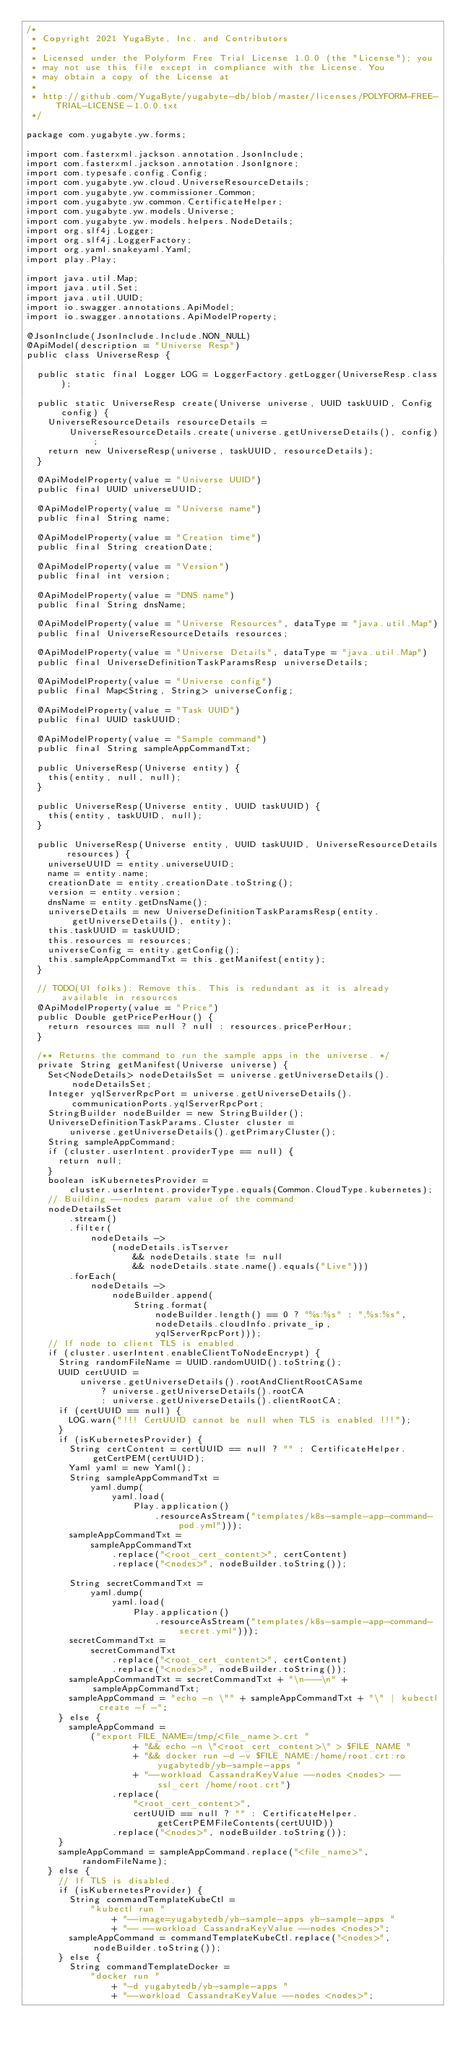<code> <loc_0><loc_0><loc_500><loc_500><_Java_>/*
 * Copyright 2021 YugaByte, Inc. and Contributors
 *
 * Licensed under the Polyform Free Trial License 1.0.0 (the "License"); you
 * may not use this file except in compliance with the License. You
 * may obtain a copy of the License at
 *
 * http://github.com/YugaByte/yugabyte-db/blob/master/licenses/POLYFORM-FREE-TRIAL-LICENSE-1.0.0.txt
 */

package com.yugabyte.yw.forms;

import com.fasterxml.jackson.annotation.JsonInclude;
import com.fasterxml.jackson.annotation.JsonIgnore;
import com.typesafe.config.Config;
import com.yugabyte.yw.cloud.UniverseResourceDetails;
import com.yugabyte.yw.commissioner.Common;
import com.yugabyte.yw.common.CertificateHelper;
import com.yugabyte.yw.models.Universe;
import com.yugabyte.yw.models.helpers.NodeDetails;
import org.slf4j.Logger;
import org.slf4j.LoggerFactory;
import org.yaml.snakeyaml.Yaml;
import play.Play;

import java.util.Map;
import java.util.Set;
import java.util.UUID;
import io.swagger.annotations.ApiModel;
import io.swagger.annotations.ApiModelProperty;

@JsonInclude(JsonInclude.Include.NON_NULL)
@ApiModel(description = "Universe Resp")
public class UniverseResp {

  public static final Logger LOG = LoggerFactory.getLogger(UniverseResp.class);

  public static UniverseResp create(Universe universe, UUID taskUUID, Config config) {
    UniverseResourceDetails resourceDetails =
        UniverseResourceDetails.create(universe.getUniverseDetails(), config);
    return new UniverseResp(universe, taskUUID, resourceDetails);
  }

  @ApiModelProperty(value = "Universe UUID")
  public final UUID universeUUID;

  @ApiModelProperty(value = "Universe name")
  public final String name;

  @ApiModelProperty(value = "Creation time")
  public final String creationDate;

  @ApiModelProperty(value = "Version")
  public final int version;

  @ApiModelProperty(value = "DNS name")
  public final String dnsName;

  @ApiModelProperty(value = "Universe Resources", dataType = "java.util.Map")
  public final UniverseResourceDetails resources;

  @ApiModelProperty(value = "Universe Details", dataType = "java.util.Map")
  public final UniverseDefinitionTaskParamsResp universeDetails;

  @ApiModelProperty(value = "Universe config")
  public final Map<String, String> universeConfig;

  @ApiModelProperty(value = "Task UUID")
  public final UUID taskUUID;

  @ApiModelProperty(value = "Sample command")
  public final String sampleAppCommandTxt;

  public UniverseResp(Universe entity) {
    this(entity, null, null);
  }

  public UniverseResp(Universe entity, UUID taskUUID) {
    this(entity, taskUUID, null);
  }

  public UniverseResp(Universe entity, UUID taskUUID, UniverseResourceDetails resources) {
    universeUUID = entity.universeUUID;
    name = entity.name;
    creationDate = entity.creationDate.toString();
    version = entity.version;
    dnsName = entity.getDnsName();
    universeDetails = new UniverseDefinitionTaskParamsResp(entity.getUniverseDetails(), entity);
    this.taskUUID = taskUUID;
    this.resources = resources;
    universeConfig = entity.getConfig();
    this.sampleAppCommandTxt = this.getManifest(entity);
  }

  // TODO(UI folks): Remove this. This is redundant as it is already available in resources
  @ApiModelProperty(value = "Price")
  public Double getPricePerHour() {
    return resources == null ? null : resources.pricePerHour;
  }

  /** Returns the command to run the sample apps in the universe. */
  private String getManifest(Universe universe) {
    Set<NodeDetails> nodeDetailsSet = universe.getUniverseDetails().nodeDetailsSet;
    Integer yqlServerRpcPort = universe.getUniverseDetails().communicationPorts.yqlServerRpcPort;
    StringBuilder nodeBuilder = new StringBuilder();
    UniverseDefinitionTaskParams.Cluster cluster =
        universe.getUniverseDetails().getPrimaryCluster();
    String sampleAppCommand;
    if (cluster.userIntent.providerType == null) {
      return null;
    }
    boolean isKubernetesProvider =
        cluster.userIntent.providerType.equals(Common.CloudType.kubernetes);
    // Building --nodes param value of the command
    nodeDetailsSet
        .stream()
        .filter(
            nodeDetails ->
                (nodeDetails.isTserver
                    && nodeDetails.state != null
                    && nodeDetails.state.name().equals("Live")))
        .forEach(
            nodeDetails ->
                nodeBuilder.append(
                    String.format(
                        nodeBuilder.length() == 0 ? "%s:%s" : ",%s:%s",
                        nodeDetails.cloudInfo.private_ip,
                        yqlServerRpcPort)));
    // If node to client TLS is enabled.
    if (cluster.userIntent.enableClientToNodeEncrypt) {
      String randomFileName = UUID.randomUUID().toString();
      UUID certUUID =
          universe.getUniverseDetails().rootAndClientRootCASame
              ? universe.getUniverseDetails().rootCA
              : universe.getUniverseDetails().clientRootCA;
      if (certUUID == null) {
        LOG.warn("!!! CertUUID cannot be null when TLS is enabled !!!");
      }
      if (isKubernetesProvider) {
        String certContent = certUUID == null ? "" : CertificateHelper.getCertPEM(certUUID);
        Yaml yaml = new Yaml();
        String sampleAppCommandTxt =
            yaml.dump(
                yaml.load(
                    Play.application()
                        .resourceAsStream("templates/k8s-sample-app-command-pod.yml")));
        sampleAppCommandTxt =
            sampleAppCommandTxt
                .replace("<root_cert_content>", certContent)
                .replace("<nodes>", nodeBuilder.toString());

        String secretCommandTxt =
            yaml.dump(
                yaml.load(
                    Play.application()
                        .resourceAsStream("templates/k8s-sample-app-command-secret.yml")));
        secretCommandTxt =
            secretCommandTxt
                .replace("<root_cert_content>", certContent)
                .replace("<nodes>", nodeBuilder.toString());
        sampleAppCommandTxt = secretCommandTxt + "\n---\n" + sampleAppCommandTxt;
        sampleAppCommand = "echo -n \"" + sampleAppCommandTxt + "\" | kubectl create -f -";
      } else {
        sampleAppCommand =
            ("export FILE_NAME=/tmp/<file_name>.crt "
                    + "&& echo -n \"<root_cert_content>\" > $FILE_NAME "
                    + "&& docker run -d -v $FILE_NAME:/home/root.crt:ro yugabytedb/yb-sample-apps "
                    + "--workload CassandraKeyValue --nodes <nodes> --ssl_cert /home/root.crt")
                .replace(
                    "<root_cert_content>",
                    certUUID == null ? "" : CertificateHelper.getCertPEMFileContents(certUUID))
                .replace("<nodes>", nodeBuilder.toString());
      }
      sampleAppCommand = sampleAppCommand.replace("<file_name>", randomFileName);
    } else {
      // If TLS is disabled.
      if (isKubernetesProvider) {
        String commandTemplateKubeCtl =
            "kubectl run "
                + "--image=yugabytedb/yb-sample-apps yb-sample-apps "
                + "-- --workload CassandraKeyValue --nodes <nodes>";
        sampleAppCommand = commandTemplateKubeCtl.replace("<nodes>", nodeBuilder.toString());
      } else {
        String commandTemplateDocker =
            "docker run "
                + "-d yugabytedb/yb-sample-apps "
                + "--workload CassandraKeyValue --nodes <nodes>";</code> 